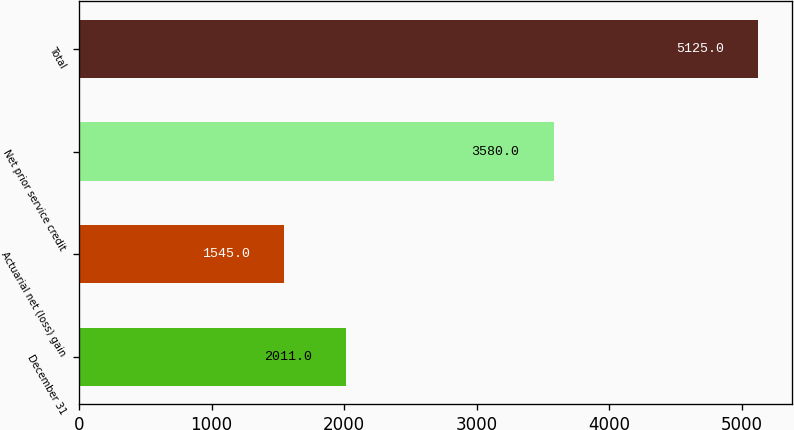<chart> <loc_0><loc_0><loc_500><loc_500><bar_chart><fcel>December 31<fcel>Actuarial net (loss) gain<fcel>Net prior service credit<fcel>Total<nl><fcel>2011<fcel>1545<fcel>3580<fcel>5125<nl></chart> 